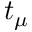Convert formula to latex. <formula><loc_0><loc_0><loc_500><loc_500>t _ { \mu }</formula> 